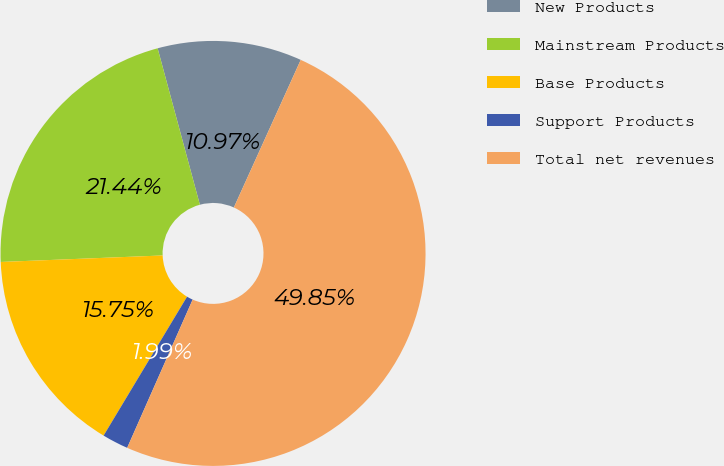Convert chart to OTSL. <chart><loc_0><loc_0><loc_500><loc_500><pie_chart><fcel>New Products<fcel>Mainstream Products<fcel>Base Products<fcel>Support Products<fcel>Total net revenues<nl><fcel>10.97%<fcel>21.44%<fcel>15.75%<fcel>1.99%<fcel>49.85%<nl></chart> 